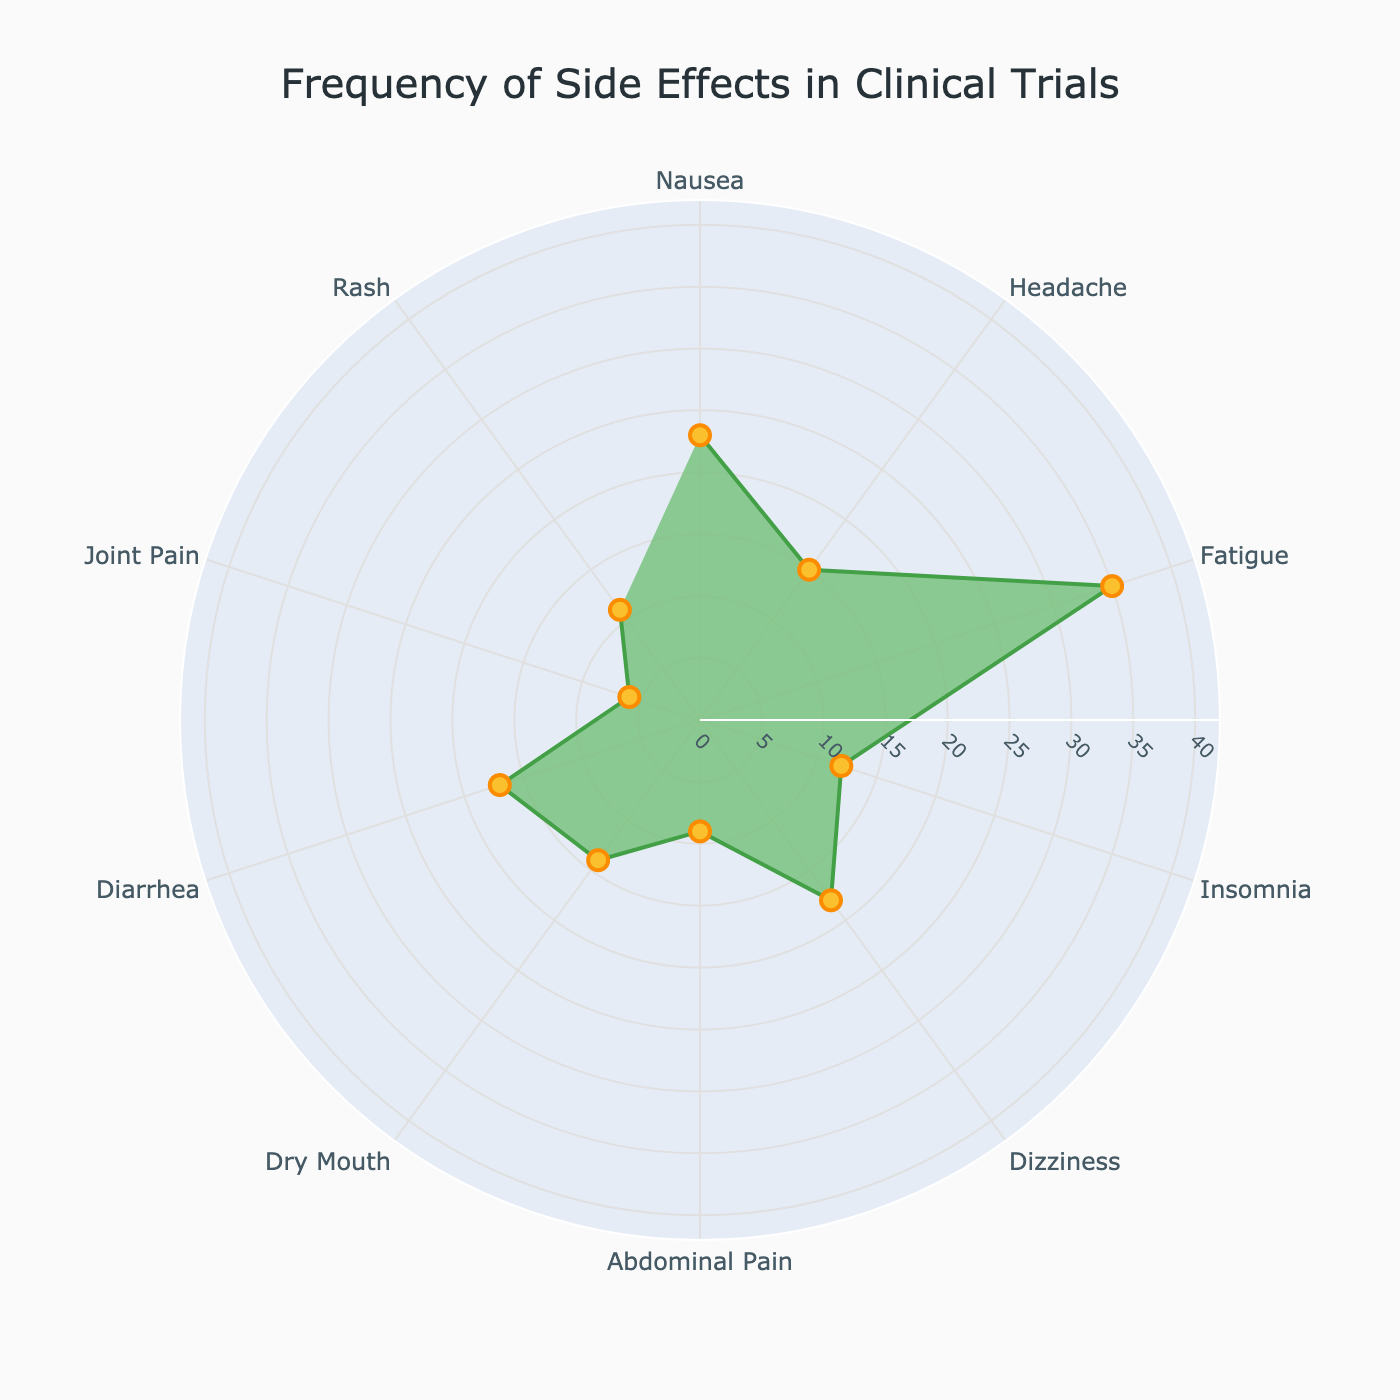What's the most frequently observed side effect? The figure shows a polar chart with various side effects and their corresponding frequencies. By observing, the side effect with the highest radius value is the most frequently observed. The highest value is 35%, attributed to Fatigue.
Answer: Fatigue How many side effects have a frequency less than 10%? The chart shows the frequency of different side effects along the radial axis. By counting the segments with radial values below 10%, we find that only one side effect (Joint Pain) meets this criterion.
Answer: 1 Which side effects have a frequency above 15%? By checking the segments with radial values greater than 15%, we identify four side effects: Nausea (23%), Fatigue (35%), Dizziness (18%), and Diarrhea (17%).
Answer: Nausea, Fatigue, Dizziness, Diarrhea What is the average frequency of all side effects? To calculate the average frequency, sum the frequencies and divide by the number of side effects. The total frequency is 160%, and there are 10 side effects. So, the average is 160/10.
Answer: 16% Is the frequency of Headache higher or lower than Insomnia? Comparing the radial values for Headache (15%) and Insomnia (12%), Headache has a higher frequency.
Answer: Higher What's the frequency difference between Nausea and Dizziness? Subtract the frequency of Dizziness (18%) from that of Nausea (23%) to find the difference.
Answer: 5% Which side effect has the lowest observed frequency? By looking at the segment with the smallest radial value, Joint Pain has the lowest frequency at 6%.
Answer: Joint Pain What is the total frequency of Dizziness, Diarrhea, and Rash combined? Add the frequencies of Dizziness (18%), Diarrhea (17%), and Rash (11%) together. The sum is 18 + 17 + 11.
Answer: 46% How does the frequency of Abdominal Pain compare to Dry Mouth? Abdominal Pain has a frequency of 9% while Dry Mouth has a frequency of 14%. Clearly, Abdominal Pain has a lower frequency than Dry Mouth.
Answer: Lower What proportion of the total frequency is contributed by Insomnia and Joint Pain together? First, we sum the frequencies of Insomnia (12%) and Joint Pain (6%) to get 18%. The total frequency of all side effects combined is 160%. The proportion is calculated as 18/160.
Answer: 11.25% 